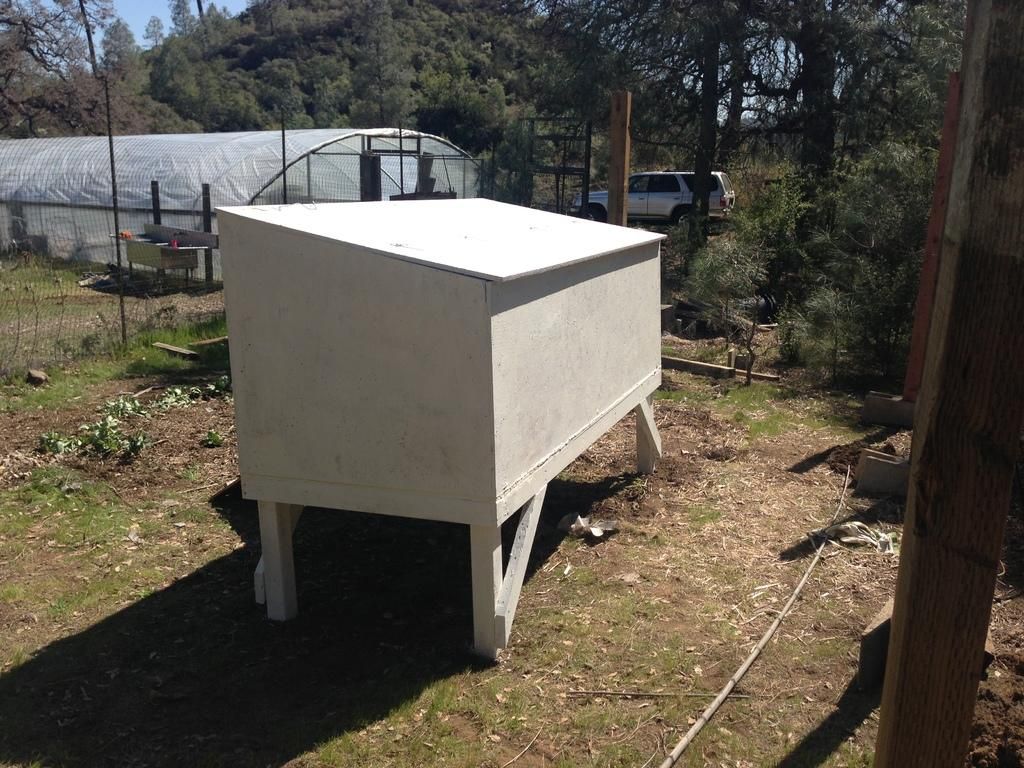What type of house is in the center of the image? There is a wooden house in the center of the image. What is at the bottom of the image? There is grass at the bottom of the image. What can be seen in the background of the image? There are trees in the background of the image. What mode of transportation is present in the image? There is a car in the image. What type of barrier is visible in the image? There is a fencing in the image. What is the tendency of the clouds in the image? There are no clouds present in the image, so it is not possible to determine their tendency. 